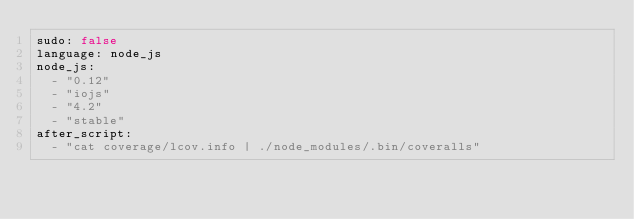<code> <loc_0><loc_0><loc_500><loc_500><_YAML_>sudo: false
language: node_js
node_js:
  - "0.12"
  - "iojs"
  - "4.2"
  - "stable"
after_script:
  - "cat coverage/lcov.info | ./node_modules/.bin/coveralls"
</code> 